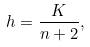Convert formula to latex. <formula><loc_0><loc_0><loc_500><loc_500>h = \frac { K } { n + 2 } ,</formula> 